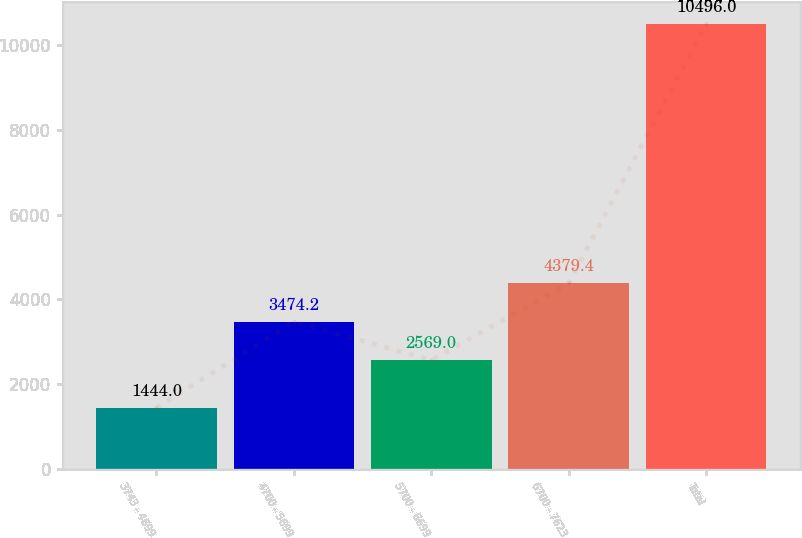Convert chart. <chart><loc_0><loc_0><loc_500><loc_500><bar_chart><fcel>3743 - 4699<fcel>4700 - 5699<fcel>5700 - 6699<fcel>6700 - 7623<fcel>Total<nl><fcel>1444<fcel>3474.2<fcel>2569<fcel>4379.4<fcel>10496<nl></chart> 